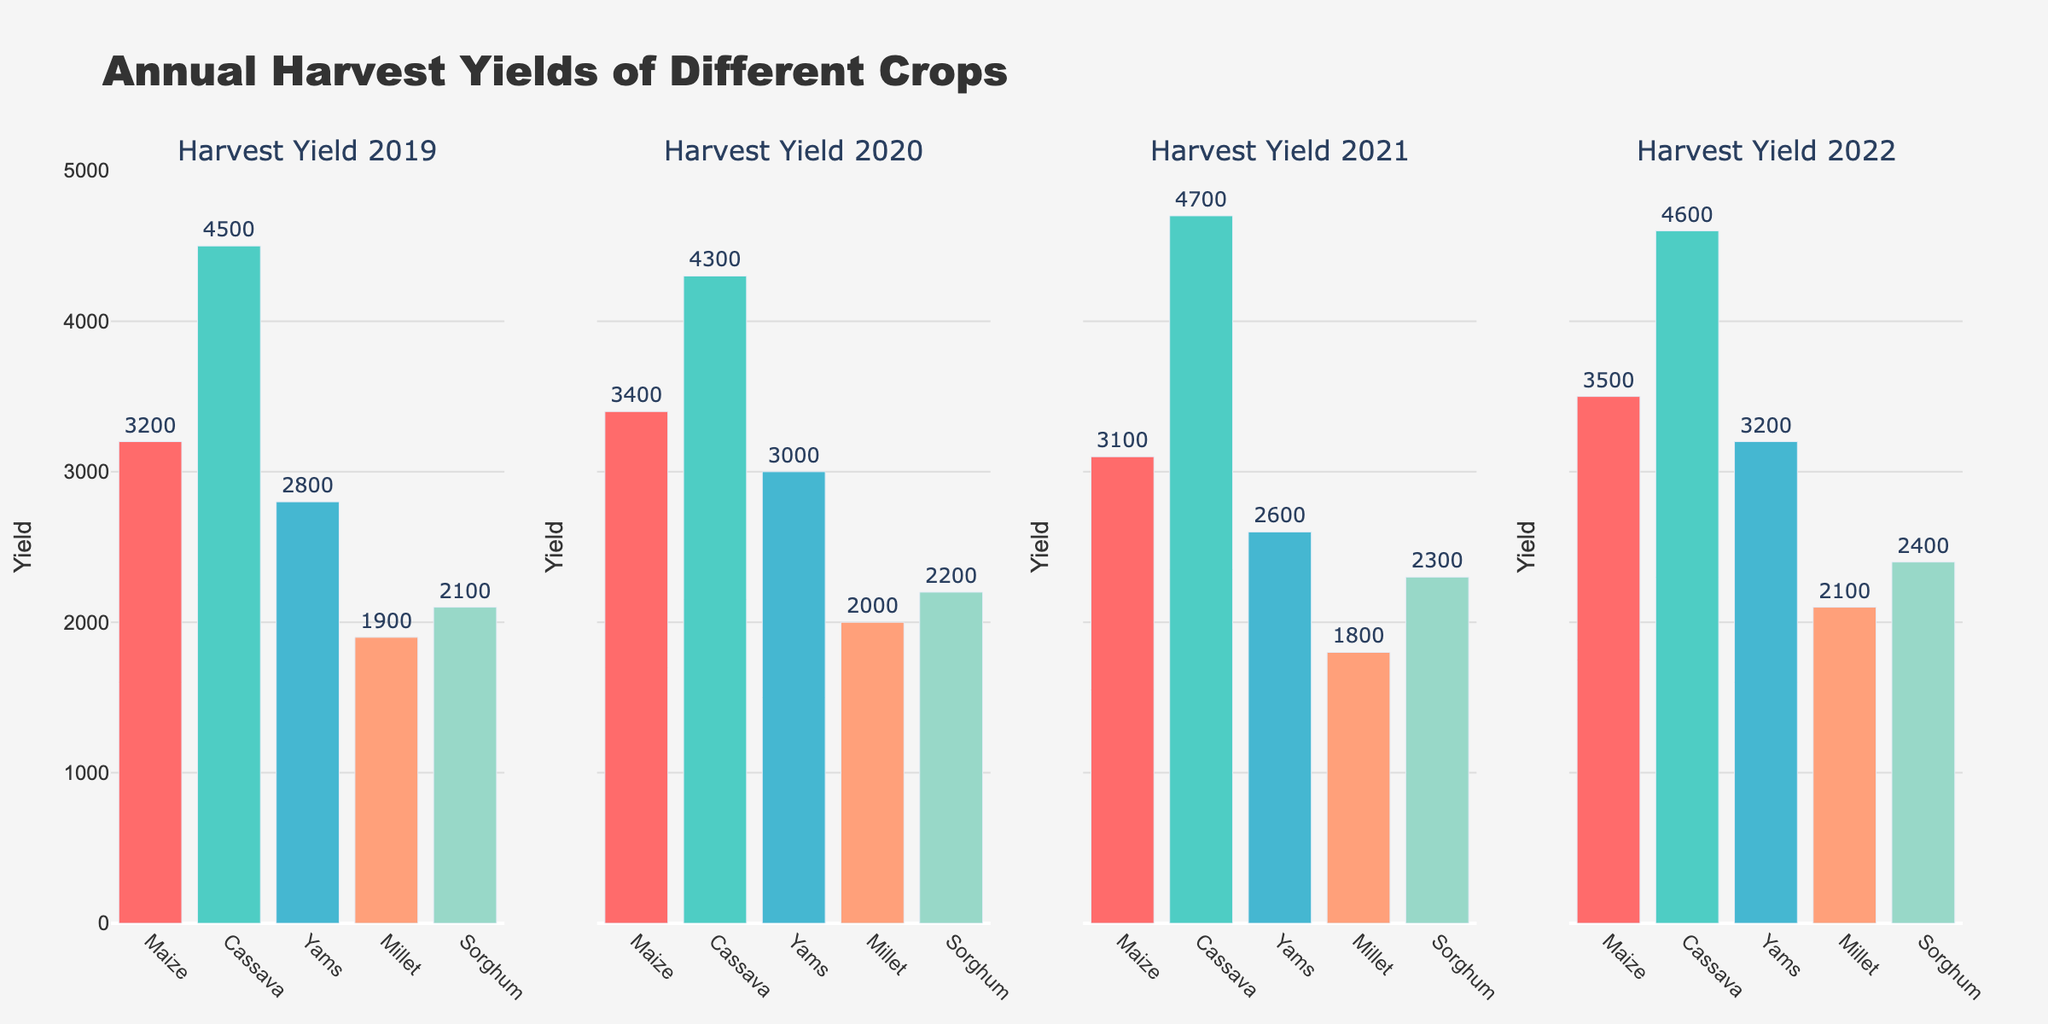What is the title of the figure? The title is displayed at the top of the figure and reads "Daniel Negreanu's Poker Tournament Performance (2013-2022)."
Answer: Daniel Negreanu's Poker Tournament Performance (2013-2022) Which year did Daniel Negreanu have the highest tournament earnings? By looking at the first subplot showing the tournament earnings for each year, you can see that the tallest bar, representing the highest earnings, is in 2014.
Answer: 2014 What was Daniel Negreanu's tournament earnings in 2020? Look for the bar corresponding to the year 2020 in the first subplot. The bar's height and label show the earnings, which is $134,091.
Answer: $134,091 How did Daniel Negreanu's earnings change from 2019 to 2020? Check the second subplot which shows the year-on-year change. The bar for 2020 shows the percentage change from 2019, which can also be calculated as ((134091 - 6928968) / 6928968) * 100%. The bar shows a steep decline of approximately -98.1%.
Answer: -98.1% In which year did Daniel Negreanu experience the largest drop in earnings compared to the previous year? By examining the second subplot (year-on-year change), the largest drop can be identified by finding the most negative bar, which occurs in 2020.
Answer: 2020 What is the average tournament earnings of Daniel Negreanu over the decade shown? Sum all the tournament earnings from the first subplot and divide by the number of years (10): (3119768 + 10284781 + 1544850 + 1619796 + 2792104 + 1780080 + 6928968 + 134091 + 1377601 + 1809760) / 10 = 31936779 / 10. The result is $3,193,678.
Answer: $3,193,678 Compare Daniel Negreanu's earnings in 2014 and 2019. Which year had higher earnings and by how much? Locate the bars for 2014 and 2019 in the first subplot. Compare the heights or values directly. Earnings in 2014 were $10,284,781 and in 2019 were $6,928,968. The difference is $10,284,781 - $6,928,968 = $3,355,813.
Answer: 2014 by $3,355,813 What color represents the highest earnings in the first subplot? Look for the bar with the highest value in the first subplot. The color of this bar, indicated by the color scale (Viridis), is a bright yellow, representing the highest earnings in 2014.
Answer: Bright yellow Which year had the smallest year-on-year change in earnings, and what was the change? Examine the second subplot for the smallest bar (closest to zero). This occurs in 2016, with a change of approximately 4.9%.
Answer: 2016, approximately 4.9% 